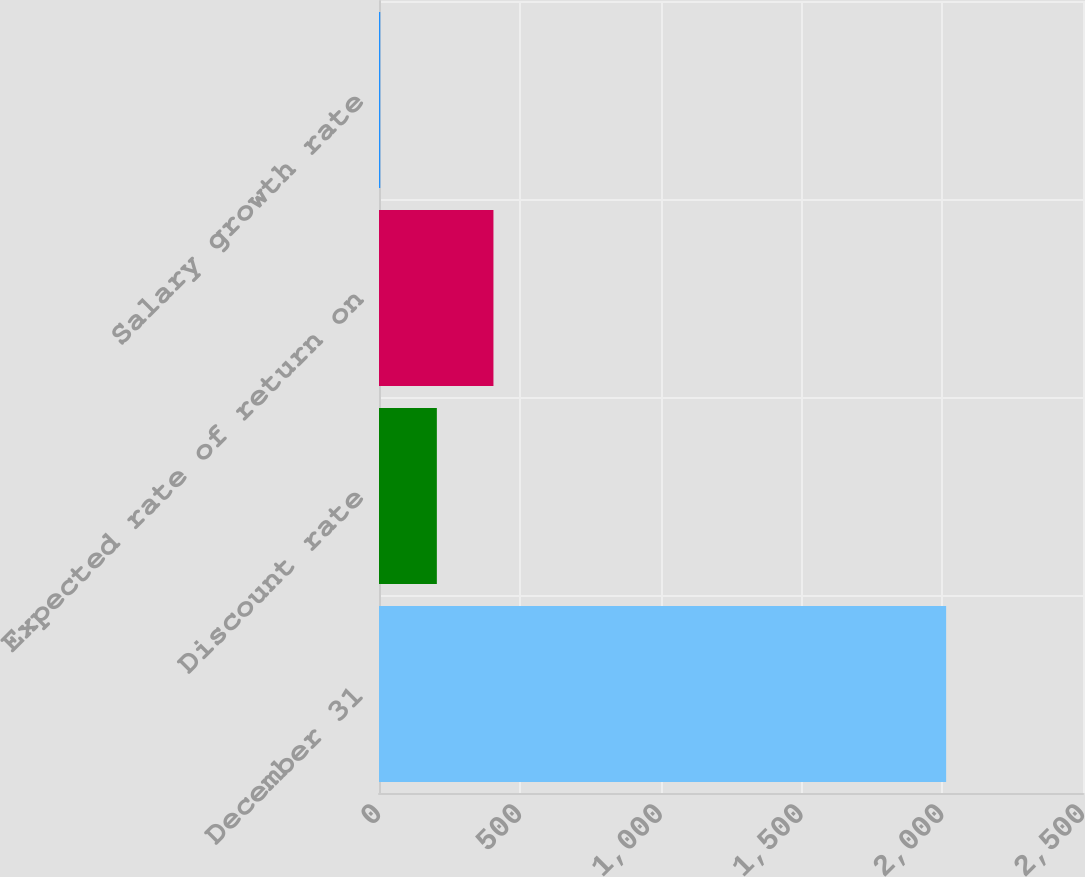Convert chart. <chart><loc_0><loc_0><loc_500><loc_500><bar_chart><fcel>December 31<fcel>Discount rate<fcel>Expected rate of return on<fcel>Salary growth rate<nl><fcel>2014<fcel>205.45<fcel>406.4<fcel>4.5<nl></chart> 